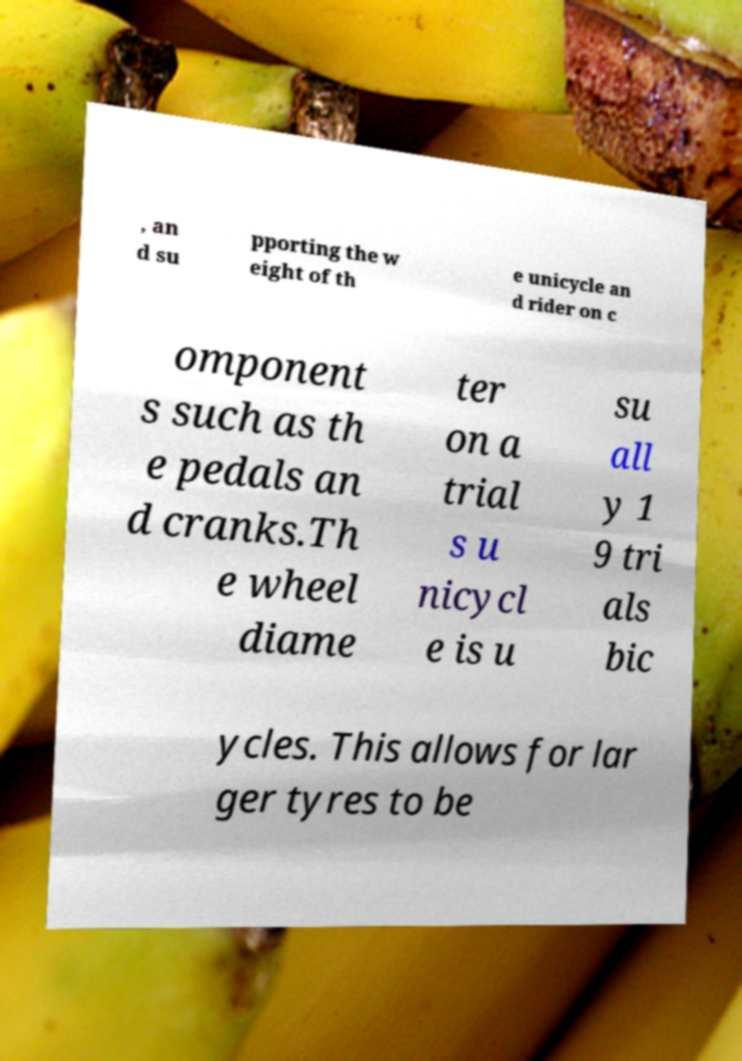There's text embedded in this image that I need extracted. Can you transcribe it verbatim? , an d su pporting the w eight of th e unicycle an d rider on c omponent s such as th e pedals an d cranks.Th e wheel diame ter on a trial s u nicycl e is u su all y 1 9 tri als bic ycles. This allows for lar ger tyres to be 